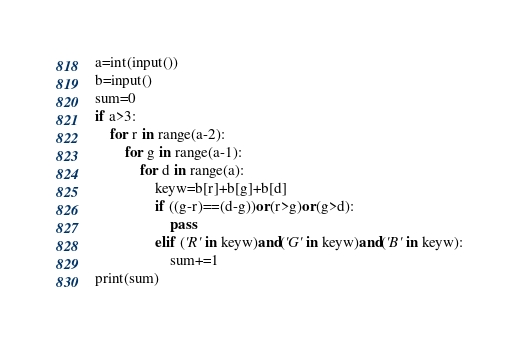Convert code to text. <code><loc_0><loc_0><loc_500><loc_500><_Python_>a=int(input())
b=input()
sum=0
if a>3:
    for r in range(a-2):
        for g in range(a-1):
            for d in range(a):
                keyw=b[r]+b[g]+b[d]
                if ((g-r)==(d-g))or(r>g)or(g>d):
                    pass
                elif ('R' in keyw)and('G' in keyw)and('B' in keyw):
                    sum+=1
print(sum)</code> 